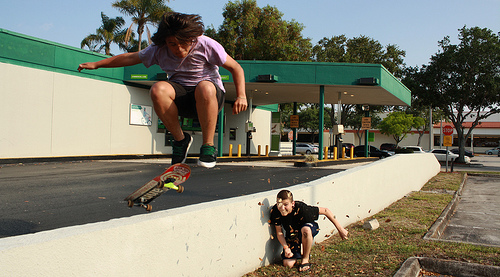Please provide the bounding box coordinate of the region this sentence describes: a small section of green grass. The coordinates [0.84, 0.54, 0.92, 0.59] accurately describe a small section of green grass at the top right of the image, providing a clear and specific location. 